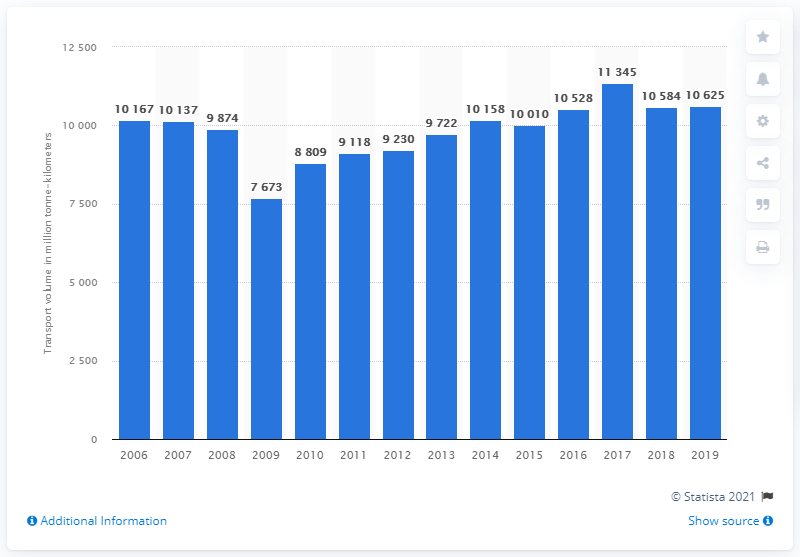Point out several critical features in this image. In 2019, the rail freight transport volume in Hungary was 10,625. 